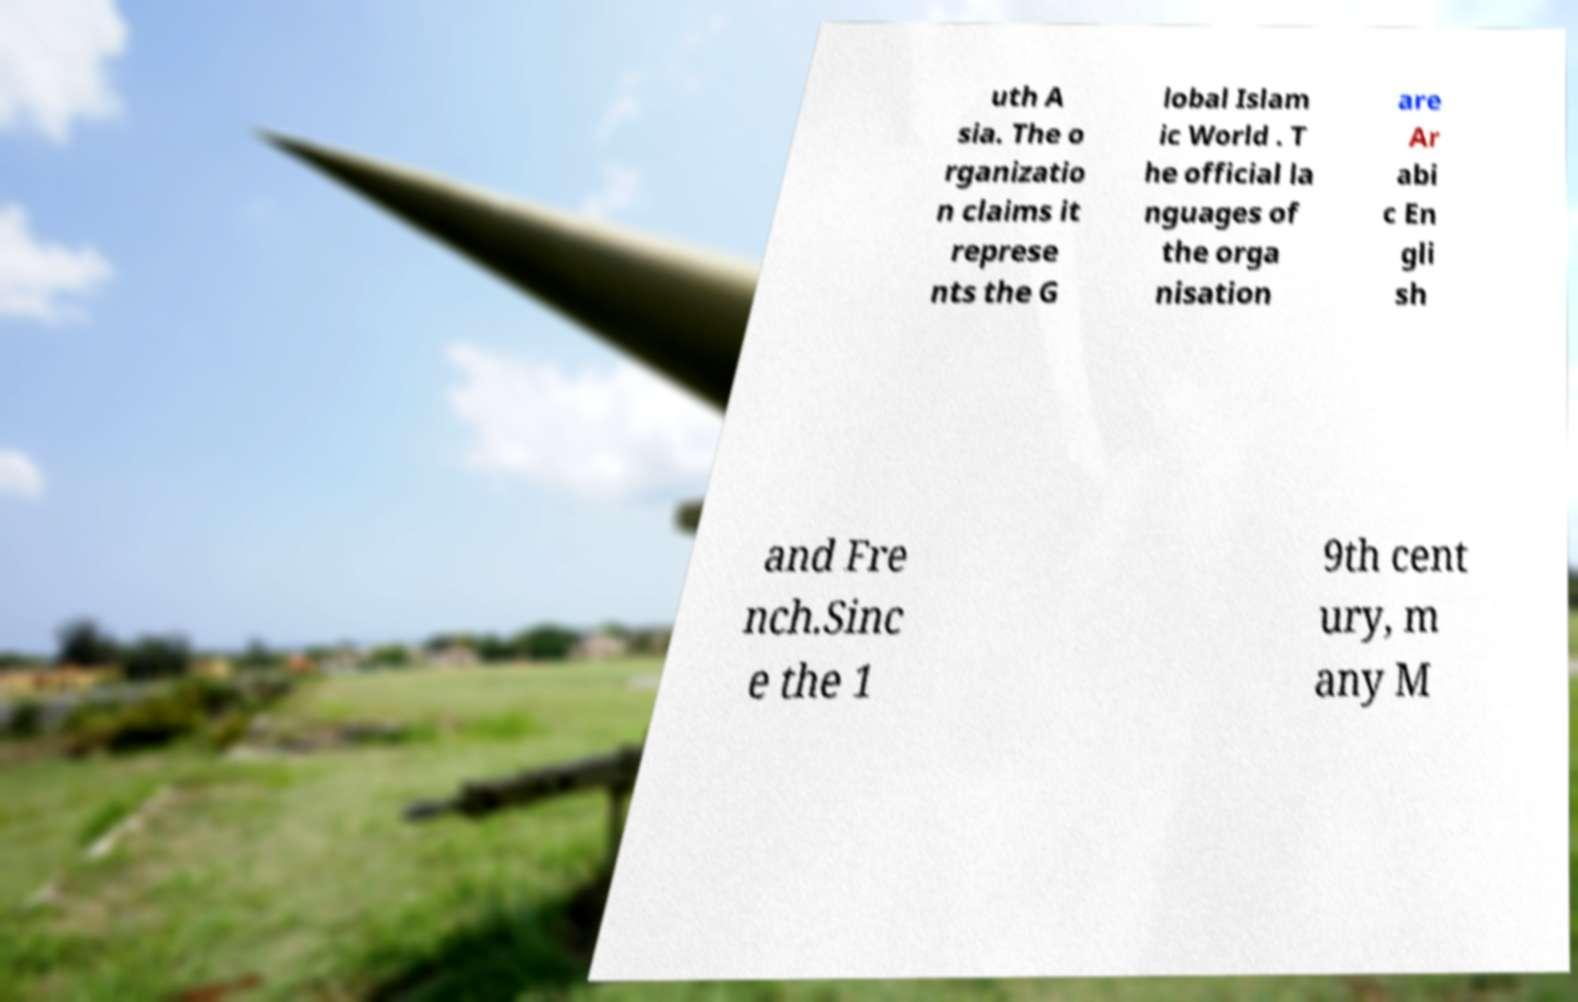Please read and relay the text visible in this image. What does it say? uth A sia. The o rganizatio n claims it represe nts the G lobal Islam ic World . T he official la nguages of the orga nisation are Ar abi c En gli sh and Fre nch.Sinc e the 1 9th cent ury, m any M 